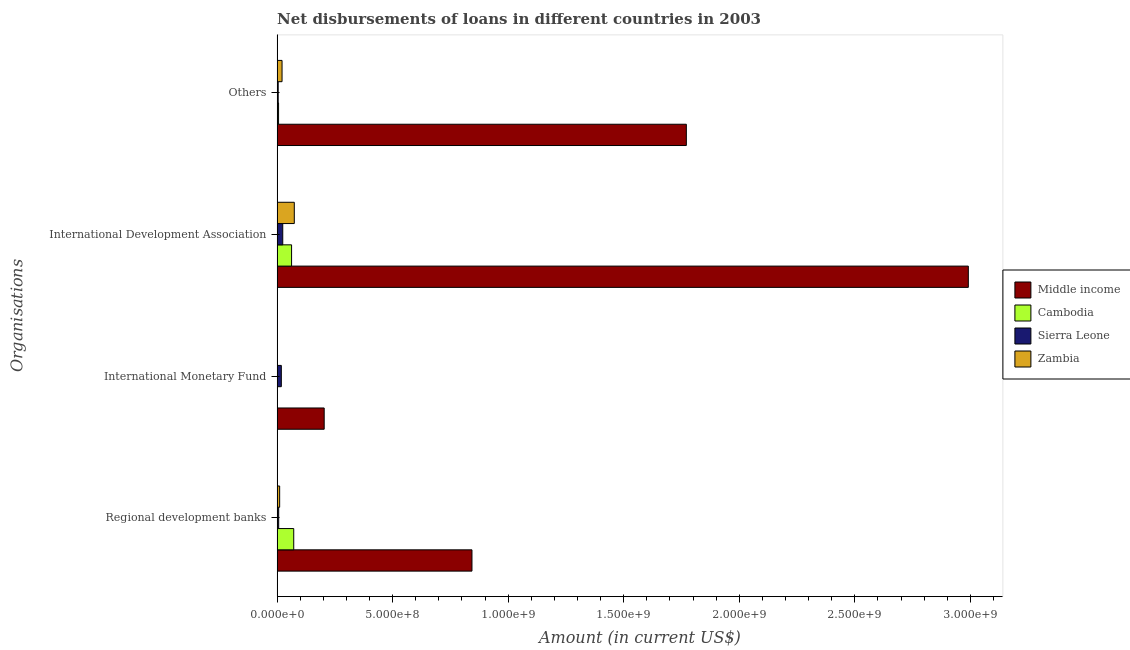How many different coloured bars are there?
Offer a terse response. 4. Are the number of bars per tick equal to the number of legend labels?
Ensure brevity in your answer.  No. How many bars are there on the 4th tick from the top?
Your response must be concise. 4. How many bars are there on the 4th tick from the bottom?
Make the answer very short. 4. What is the label of the 1st group of bars from the top?
Offer a very short reply. Others. What is the amount of loan disimbursed by international monetary fund in Sierra Leone?
Ensure brevity in your answer.  1.82e+07. Across all countries, what is the maximum amount of loan disimbursed by regional development banks?
Offer a terse response. 8.43e+08. Across all countries, what is the minimum amount of loan disimbursed by international development association?
Provide a short and direct response. 2.43e+07. What is the total amount of loan disimbursed by other organisations in the graph?
Keep it short and to the point. 1.80e+09. What is the difference between the amount of loan disimbursed by regional development banks in Middle income and that in Sierra Leone?
Your answer should be compact. 8.36e+08. What is the difference between the amount of loan disimbursed by international development association in Zambia and the amount of loan disimbursed by regional development banks in Middle income?
Keep it short and to the point. -7.69e+08. What is the average amount of loan disimbursed by regional development banks per country?
Keep it short and to the point. 2.33e+08. What is the difference between the amount of loan disimbursed by regional development banks and amount of loan disimbursed by other organisations in Zambia?
Offer a very short reply. -1.03e+07. In how many countries, is the amount of loan disimbursed by international monetary fund greater than 1700000000 US$?
Your response must be concise. 0. What is the ratio of the amount of loan disimbursed by international development association in Zambia to that in Middle income?
Keep it short and to the point. 0.02. Is the amount of loan disimbursed by other organisations in Zambia less than that in Sierra Leone?
Provide a succinct answer. No. Is the difference between the amount of loan disimbursed by international development association in Zambia and Sierra Leone greater than the difference between the amount of loan disimbursed by other organisations in Zambia and Sierra Leone?
Your answer should be very brief. Yes. What is the difference between the highest and the second highest amount of loan disimbursed by other organisations?
Ensure brevity in your answer.  1.75e+09. What is the difference between the highest and the lowest amount of loan disimbursed by international development association?
Keep it short and to the point. 2.97e+09. How many bars are there?
Keep it short and to the point. 14. Are all the bars in the graph horizontal?
Your answer should be very brief. Yes. Does the graph contain grids?
Your answer should be very brief. No. Where does the legend appear in the graph?
Ensure brevity in your answer.  Center right. How many legend labels are there?
Offer a terse response. 4. How are the legend labels stacked?
Give a very brief answer. Vertical. What is the title of the graph?
Provide a short and direct response. Net disbursements of loans in different countries in 2003. Does "Morocco" appear as one of the legend labels in the graph?
Ensure brevity in your answer.  No. What is the label or title of the Y-axis?
Offer a very short reply. Organisations. What is the Amount (in current US$) in Middle income in Regional development banks?
Your answer should be compact. 8.43e+08. What is the Amount (in current US$) of Cambodia in Regional development banks?
Keep it short and to the point. 7.18e+07. What is the Amount (in current US$) in Sierra Leone in Regional development banks?
Your response must be concise. 6.79e+06. What is the Amount (in current US$) of Zambia in Regional development banks?
Ensure brevity in your answer.  1.10e+07. What is the Amount (in current US$) in Middle income in International Monetary Fund?
Offer a terse response. 2.04e+08. What is the Amount (in current US$) of Cambodia in International Monetary Fund?
Your response must be concise. 0. What is the Amount (in current US$) in Sierra Leone in International Monetary Fund?
Offer a terse response. 1.82e+07. What is the Amount (in current US$) in Zambia in International Monetary Fund?
Offer a very short reply. 0. What is the Amount (in current US$) of Middle income in International Development Association?
Provide a short and direct response. 2.99e+09. What is the Amount (in current US$) in Cambodia in International Development Association?
Provide a succinct answer. 6.26e+07. What is the Amount (in current US$) in Sierra Leone in International Development Association?
Your response must be concise. 2.43e+07. What is the Amount (in current US$) of Zambia in International Development Association?
Ensure brevity in your answer.  7.43e+07. What is the Amount (in current US$) of Middle income in Others?
Offer a very short reply. 1.77e+09. What is the Amount (in current US$) of Cambodia in Others?
Provide a succinct answer. 6.24e+06. What is the Amount (in current US$) in Sierra Leone in Others?
Provide a short and direct response. 4.61e+06. What is the Amount (in current US$) in Zambia in Others?
Give a very brief answer. 2.13e+07. Across all Organisations, what is the maximum Amount (in current US$) in Middle income?
Ensure brevity in your answer.  2.99e+09. Across all Organisations, what is the maximum Amount (in current US$) in Cambodia?
Give a very brief answer. 7.18e+07. Across all Organisations, what is the maximum Amount (in current US$) of Sierra Leone?
Give a very brief answer. 2.43e+07. Across all Organisations, what is the maximum Amount (in current US$) of Zambia?
Offer a terse response. 7.43e+07. Across all Organisations, what is the minimum Amount (in current US$) in Middle income?
Offer a terse response. 2.04e+08. Across all Organisations, what is the minimum Amount (in current US$) of Sierra Leone?
Make the answer very short. 4.61e+06. Across all Organisations, what is the minimum Amount (in current US$) of Zambia?
Your answer should be compact. 0. What is the total Amount (in current US$) of Middle income in the graph?
Provide a short and direct response. 5.81e+09. What is the total Amount (in current US$) in Cambodia in the graph?
Offer a very short reply. 1.41e+08. What is the total Amount (in current US$) of Sierra Leone in the graph?
Offer a terse response. 5.39e+07. What is the total Amount (in current US$) of Zambia in the graph?
Ensure brevity in your answer.  1.07e+08. What is the difference between the Amount (in current US$) in Middle income in Regional development banks and that in International Monetary Fund?
Provide a succinct answer. 6.40e+08. What is the difference between the Amount (in current US$) in Sierra Leone in Regional development banks and that in International Monetary Fund?
Offer a terse response. -1.14e+07. What is the difference between the Amount (in current US$) of Middle income in Regional development banks and that in International Development Association?
Your response must be concise. -2.15e+09. What is the difference between the Amount (in current US$) in Cambodia in Regional development banks and that in International Development Association?
Your response must be concise. 9.28e+06. What is the difference between the Amount (in current US$) of Sierra Leone in Regional development banks and that in International Development Association?
Ensure brevity in your answer.  -1.75e+07. What is the difference between the Amount (in current US$) in Zambia in Regional development banks and that in International Development Association?
Make the answer very short. -6.33e+07. What is the difference between the Amount (in current US$) in Middle income in Regional development banks and that in Others?
Offer a terse response. -9.28e+08. What is the difference between the Amount (in current US$) of Cambodia in Regional development banks and that in Others?
Keep it short and to the point. 6.56e+07. What is the difference between the Amount (in current US$) of Sierra Leone in Regional development banks and that in Others?
Offer a very short reply. 2.18e+06. What is the difference between the Amount (in current US$) of Zambia in Regional development banks and that in Others?
Make the answer very short. -1.03e+07. What is the difference between the Amount (in current US$) of Middle income in International Monetary Fund and that in International Development Association?
Keep it short and to the point. -2.79e+09. What is the difference between the Amount (in current US$) of Sierra Leone in International Monetary Fund and that in International Development Association?
Your answer should be compact. -6.14e+06. What is the difference between the Amount (in current US$) of Middle income in International Monetary Fund and that in Others?
Keep it short and to the point. -1.57e+09. What is the difference between the Amount (in current US$) of Sierra Leone in International Monetary Fund and that in Others?
Your response must be concise. 1.36e+07. What is the difference between the Amount (in current US$) in Middle income in International Development Association and that in Others?
Your answer should be compact. 1.22e+09. What is the difference between the Amount (in current US$) of Cambodia in International Development Association and that in Others?
Offer a terse response. 5.63e+07. What is the difference between the Amount (in current US$) in Sierra Leone in International Development Association and that in Others?
Your response must be concise. 1.97e+07. What is the difference between the Amount (in current US$) in Zambia in International Development Association and that in Others?
Make the answer very short. 5.30e+07. What is the difference between the Amount (in current US$) of Middle income in Regional development banks and the Amount (in current US$) of Sierra Leone in International Monetary Fund?
Your answer should be compact. 8.25e+08. What is the difference between the Amount (in current US$) of Cambodia in Regional development banks and the Amount (in current US$) of Sierra Leone in International Monetary Fund?
Your answer should be very brief. 5.37e+07. What is the difference between the Amount (in current US$) of Middle income in Regional development banks and the Amount (in current US$) of Cambodia in International Development Association?
Your answer should be very brief. 7.81e+08. What is the difference between the Amount (in current US$) of Middle income in Regional development banks and the Amount (in current US$) of Sierra Leone in International Development Association?
Give a very brief answer. 8.19e+08. What is the difference between the Amount (in current US$) in Middle income in Regional development banks and the Amount (in current US$) in Zambia in International Development Association?
Offer a very short reply. 7.69e+08. What is the difference between the Amount (in current US$) of Cambodia in Regional development banks and the Amount (in current US$) of Sierra Leone in International Development Association?
Offer a very short reply. 4.75e+07. What is the difference between the Amount (in current US$) of Cambodia in Regional development banks and the Amount (in current US$) of Zambia in International Development Association?
Provide a short and direct response. -2.44e+06. What is the difference between the Amount (in current US$) in Sierra Leone in Regional development banks and the Amount (in current US$) in Zambia in International Development Association?
Give a very brief answer. -6.75e+07. What is the difference between the Amount (in current US$) of Middle income in Regional development banks and the Amount (in current US$) of Cambodia in Others?
Provide a succinct answer. 8.37e+08. What is the difference between the Amount (in current US$) of Middle income in Regional development banks and the Amount (in current US$) of Sierra Leone in Others?
Offer a very short reply. 8.39e+08. What is the difference between the Amount (in current US$) in Middle income in Regional development banks and the Amount (in current US$) in Zambia in Others?
Your answer should be very brief. 8.22e+08. What is the difference between the Amount (in current US$) in Cambodia in Regional development banks and the Amount (in current US$) in Sierra Leone in Others?
Ensure brevity in your answer.  6.72e+07. What is the difference between the Amount (in current US$) of Cambodia in Regional development banks and the Amount (in current US$) of Zambia in Others?
Your answer should be compact. 5.06e+07. What is the difference between the Amount (in current US$) of Sierra Leone in Regional development banks and the Amount (in current US$) of Zambia in Others?
Keep it short and to the point. -1.45e+07. What is the difference between the Amount (in current US$) in Middle income in International Monetary Fund and the Amount (in current US$) in Cambodia in International Development Association?
Make the answer very short. 1.41e+08. What is the difference between the Amount (in current US$) in Middle income in International Monetary Fund and the Amount (in current US$) in Sierra Leone in International Development Association?
Offer a very short reply. 1.79e+08. What is the difference between the Amount (in current US$) of Middle income in International Monetary Fund and the Amount (in current US$) of Zambia in International Development Association?
Keep it short and to the point. 1.29e+08. What is the difference between the Amount (in current US$) of Sierra Leone in International Monetary Fund and the Amount (in current US$) of Zambia in International Development Association?
Provide a short and direct response. -5.61e+07. What is the difference between the Amount (in current US$) of Middle income in International Monetary Fund and the Amount (in current US$) of Cambodia in Others?
Provide a succinct answer. 1.97e+08. What is the difference between the Amount (in current US$) of Middle income in International Monetary Fund and the Amount (in current US$) of Sierra Leone in Others?
Give a very brief answer. 1.99e+08. What is the difference between the Amount (in current US$) in Middle income in International Monetary Fund and the Amount (in current US$) in Zambia in Others?
Your response must be concise. 1.82e+08. What is the difference between the Amount (in current US$) of Sierra Leone in International Monetary Fund and the Amount (in current US$) of Zambia in Others?
Offer a very short reply. -3.10e+06. What is the difference between the Amount (in current US$) in Middle income in International Development Association and the Amount (in current US$) in Cambodia in Others?
Your answer should be very brief. 2.99e+09. What is the difference between the Amount (in current US$) in Middle income in International Development Association and the Amount (in current US$) in Sierra Leone in Others?
Provide a short and direct response. 2.99e+09. What is the difference between the Amount (in current US$) of Middle income in International Development Association and the Amount (in current US$) of Zambia in Others?
Your response must be concise. 2.97e+09. What is the difference between the Amount (in current US$) in Cambodia in International Development Association and the Amount (in current US$) in Sierra Leone in Others?
Your response must be concise. 5.79e+07. What is the difference between the Amount (in current US$) in Cambodia in International Development Association and the Amount (in current US$) in Zambia in Others?
Provide a succinct answer. 4.13e+07. What is the difference between the Amount (in current US$) in Sierra Leone in International Development Association and the Amount (in current US$) in Zambia in Others?
Ensure brevity in your answer.  3.03e+06. What is the average Amount (in current US$) in Middle income per Organisations?
Make the answer very short. 1.45e+09. What is the average Amount (in current US$) in Cambodia per Organisations?
Offer a very short reply. 3.52e+07. What is the average Amount (in current US$) of Sierra Leone per Organisations?
Your answer should be very brief. 1.35e+07. What is the average Amount (in current US$) in Zambia per Organisations?
Your answer should be very brief. 2.66e+07. What is the difference between the Amount (in current US$) of Middle income and Amount (in current US$) of Cambodia in Regional development banks?
Your answer should be compact. 7.71e+08. What is the difference between the Amount (in current US$) in Middle income and Amount (in current US$) in Sierra Leone in Regional development banks?
Provide a succinct answer. 8.36e+08. What is the difference between the Amount (in current US$) in Middle income and Amount (in current US$) in Zambia in Regional development banks?
Your answer should be very brief. 8.32e+08. What is the difference between the Amount (in current US$) of Cambodia and Amount (in current US$) of Sierra Leone in Regional development banks?
Ensure brevity in your answer.  6.51e+07. What is the difference between the Amount (in current US$) of Cambodia and Amount (in current US$) of Zambia in Regional development banks?
Offer a very short reply. 6.09e+07. What is the difference between the Amount (in current US$) of Sierra Leone and Amount (in current US$) of Zambia in Regional development banks?
Give a very brief answer. -4.19e+06. What is the difference between the Amount (in current US$) of Middle income and Amount (in current US$) of Sierra Leone in International Monetary Fund?
Your answer should be very brief. 1.85e+08. What is the difference between the Amount (in current US$) in Middle income and Amount (in current US$) in Cambodia in International Development Association?
Provide a short and direct response. 2.93e+09. What is the difference between the Amount (in current US$) in Middle income and Amount (in current US$) in Sierra Leone in International Development Association?
Ensure brevity in your answer.  2.97e+09. What is the difference between the Amount (in current US$) of Middle income and Amount (in current US$) of Zambia in International Development Association?
Your response must be concise. 2.92e+09. What is the difference between the Amount (in current US$) in Cambodia and Amount (in current US$) in Sierra Leone in International Development Association?
Provide a succinct answer. 3.82e+07. What is the difference between the Amount (in current US$) in Cambodia and Amount (in current US$) in Zambia in International Development Association?
Your answer should be very brief. -1.17e+07. What is the difference between the Amount (in current US$) of Sierra Leone and Amount (in current US$) of Zambia in International Development Association?
Provide a short and direct response. -5.00e+07. What is the difference between the Amount (in current US$) of Middle income and Amount (in current US$) of Cambodia in Others?
Offer a very short reply. 1.76e+09. What is the difference between the Amount (in current US$) in Middle income and Amount (in current US$) in Sierra Leone in Others?
Your answer should be very brief. 1.77e+09. What is the difference between the Amount (in current US$) of Middle income and Amount (in current US$) of Zambia in Others?
Provide a succinct answer. 1.75e+09. What is the difference between the Amount (in current US$) in Cambodia and Amount (in current US$) in Sierra Leone in Others?
Ensure brevity in your answer.  1.63e+06. What is the difference between the Amount (in current US$) in Cambodia and Amount (in current US$) in Zambia in Others?
Ensure brevity in your answer.  -1.50e+07. What is the difference between the Amount (in current US$) in Sierra Leone and Amount (in current US$) in Zambia in Others?
Provide a succinct answer. -1.67e+07. What is the ratio of the Amount (in current US$) in Middle income in Regional development banks to that in International Monetary Fund?
Provide a short and direct response. 4.14. What is the ratio of the Amount (in current US$) in Sierra Leone in Regional development banks to that in International Monetary Fund?
Keep it short and to the point. 0.37. What is the ratio of the Amount (in current US$) of Middle income in Regional development banks to that in International Development Association?
Offer a very short reply. 0.28. What is the ratio of the Amount (in current US$) in Cambodia in Regional development banks to that in International Development Association?
Provide a succinct answer. 1.15. What is the ratio of the Amount (in current US$) in Sierra Leone in Regional development banks to that in International Development Association?
Your answer should be very brief. 0.28. What is the ratio of the Amount (in current US$) of Zambia in Regional development banks to that in International Development Association?
Offer a terse response. 0.15. What is the ratio of the Amount (in current US$) of Middle income in Regional development banks to that in Others?
Your answer should be compact. 0.48. What is the ratio of the Amount (in current US$) of Cambodia in Regional development banks to that in Others?
Ensure brevity in your answer.  11.51. What is the ratio of the Amount (in current US$) in Sierra Leone in Regional development banks to that in Others?
Keep it short and to the point. 1.47. What is the ratio of the Amount (in current US$) of Zambia in Regional development banks to that in Others?
Give a very brief answer. 0.52. What is the ratio of the Amount (in current US$) in Middle income in International Monetary Fund to that in International Development Association?
Your response must be concise. 0.07. What is the ratio of the Amount (in current US$) in Sierra Leone in International Monetary Fund to that in International Development Association?
Provide a short and direct response. 0.75. What is the ratio of the Amount (in current US$) of Middle income in International Monetary Fund to that in Others?
Offer a terse response. 0.12. What is the ratio of the Amount (in current US$) in Sierra Leone in International Monetary Fund to that in Others?
Your answer should be compact. 3.94. What is the ratio of the Amount (in current US$) of Middle income in International Development Association to that in Others?
Your answer should be compact. 1.69. What is the ratio of the Amount (in current US$) of Cambodia in International Development Association to that in Others?
Provide a succinct answer. 10.02. What is the ratio of the Amount (in current US$) in Sierra Leone in International Development Association to that in Others?
Keep it short and to the point. 5.27. What is the ratio of the Amount (in current US$) of Zambia in International Development Association to that in Others?
Your answer should be compact. 3.49. What is the difference between the highest and the second highest Amount (in current US$) in Middle income?
Offer a very short reply. 1.22e+09. What is the difference between the highest and the second highest Amount (in current US$) in Cambodia?
Provide a short and direct response. 9.28e+06. What is the difference between the highest and the second highest Amount (in current US$) of Sierra Leone?
Your answer should be compact. 6.14e+06. What is the difference between the highest and the second highest Amount (in current US$) of Zambia?
Offer a terse response. 5.30e+07. What is the difference between the highest and the lowest Amount (in current US$) in Middle income?
Provide a short and direct response. 2.79e+09. What is the difference between the highest and the lowest Amount (in current US$) of Cambodia?
Offer a terse response. 7.18e+07. What is the difference between the highest and the lowest Amount (in current US$) of Sierra Leone?
Your answer should be compact. 1.97e+07. What is the difference between the highest and the lowest Amount (in current US$) in Zambia?
Provide a succinct answer. 7.43e+07. 